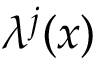<formula> <loc_0><loc_0><loc_500><loc_500>\lambda ^ { j } ( x )</formula> 